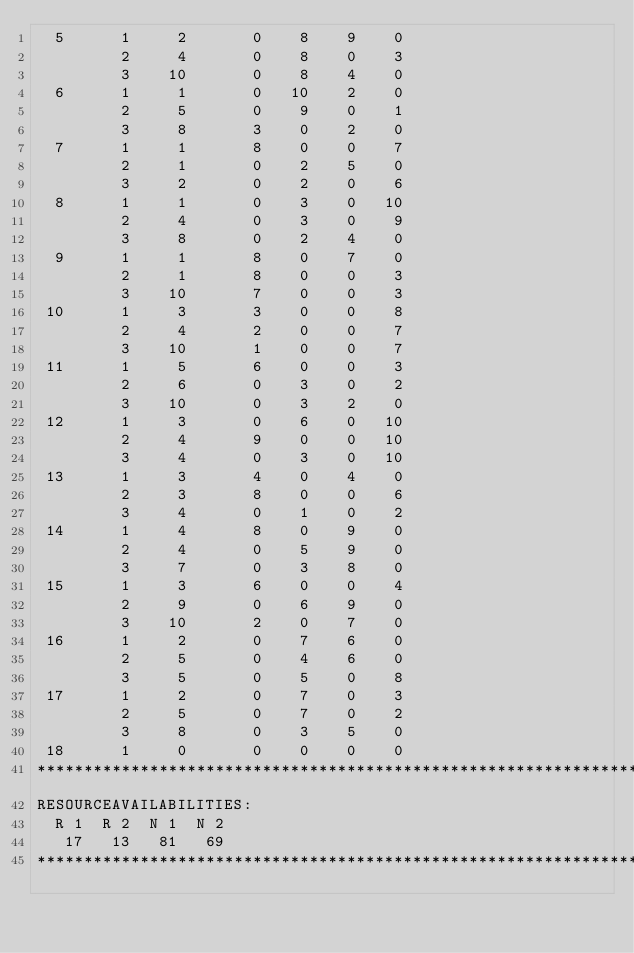<code> <loc_0><loc_0><loc_500><loc_500><_ObjectiveC_>  5      1     2       0    8    9    0
         2     4       0    8    0    3
         3    10       0    8    4    0
  6      1     1       0   10    2    0
         2     5       0    9    0    1
         3     8       3    0    2    0
  7      1     1       8    0    0    7
         2     1       0    2    5    0
         3     2       0    2    0    6
  8      1     1       0    3    0   10
         2     4       0    3    0    9
         3     8       0    2    4    0
  9      1     1       8    0    7    0
         2     1       8    0    0    3
         3    10       7    0    0    3
 10      1     3       3    0    0    8
         2     4       2    0    0    7
         3    10       1    0    0    7
 11      1     5       6    0    0    3
         2     6       0    3    0    2
         3    10       0    3    2    0
 12      1     3       0    6    0   10
         2     4       9    0    0   10
         3     4       0    3    0   10
 13      1     3       4    0    4    0
         2     3       8    0    0    6
         3     4       0    1    0    2
 14      1     4       8    0    9    0
         2     4       0    5    9    0
         3     7       0    3    8    0
 15      1     3       6    0    0    4
         2     9       0    6    9    0
         3    10       2    0    7    0
 16      1     2       0    7    6    0
         2     5       0    4    6    0
         3     5       0    5    0    8
 17      1     2       0    7    0    3
         2     5       0    7    0    2
         3     8       0    3    5    0
 18      1     0       0    0    0    0
************************************************************************
RESOURCEAVAILABILITIES:
  R 1  R 2  N 1  N 2
   17   13   81   69
************************************************************************
</code> 